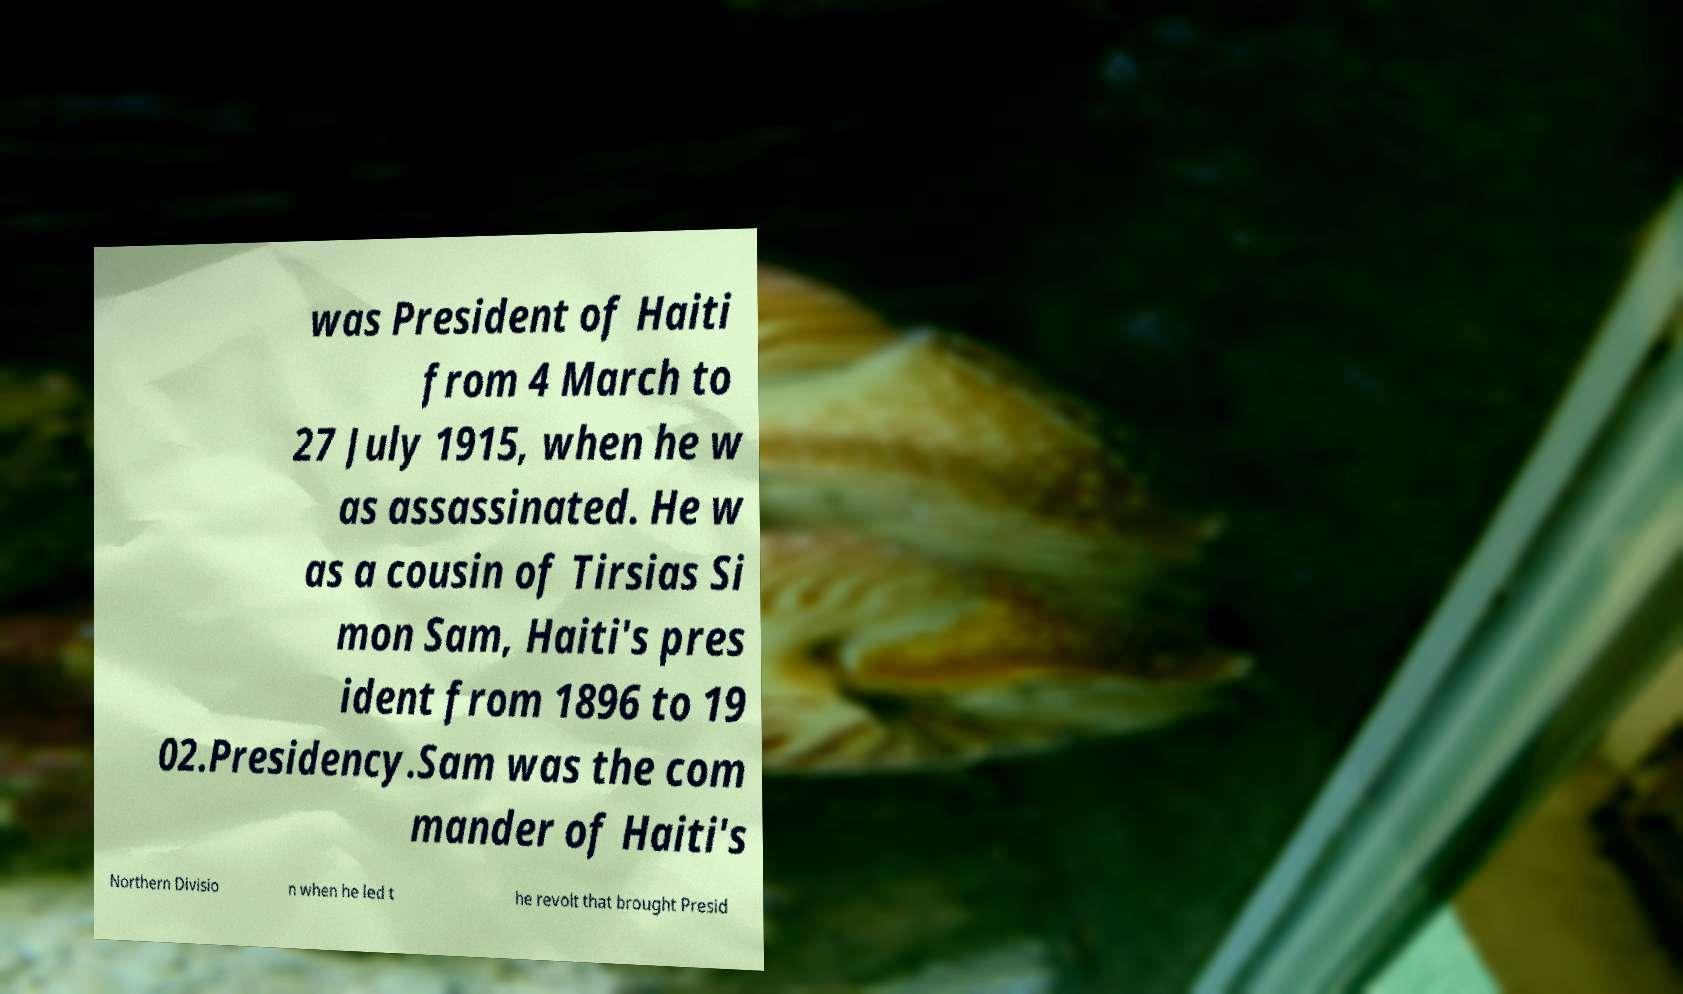Please read and relay the text visible in this image. What does it say? was President of Haiti from 4 March to 27 July 1915, when he w as assassinated. He w as a cousin of Tirsias Si mon Sam, Haiti's pres ident from 1896 to 19 02.Presidency.Sam was the com mander of Haiti's Northern Divisio n when he led t he revolt that brought Presid 